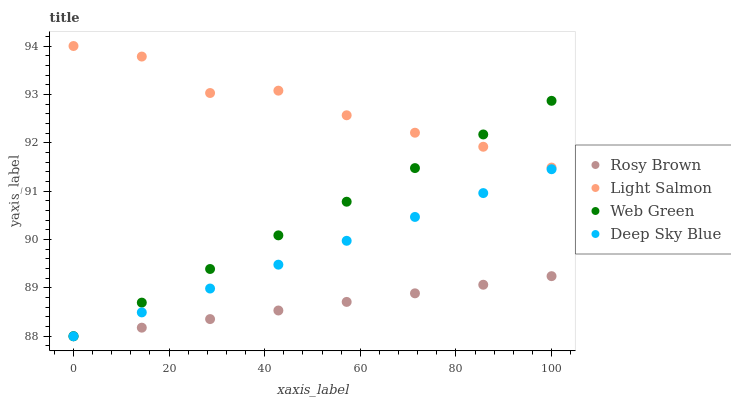Does Rosy Brown have the minimum area under the curve?
Answer yes or no. Yes. Does Light Salmon have the maximum area under the curve?
Answer yes or no. Yes. Does Deep Sky Blue have the minimum area under the curve?
Answer yes or no. No. Does Deep Sky Blue have the maximum area under the curve?
Answer yes or no. No. Is Rosy Brown the smoothest?
Answer yes or no. Yes. Is Light Salmon the roughest?
Answer yes or no. Yes. Is Deep Sky Blue the smoothest?
Answer yes or no. No. Is Deep Sky Blue the roughest?
Answer yes or no. No. Does Rosy Brown have the lowest value?
Answer yes or no. Yes. Does Light Salmon have the highest value?
Answer yes or no. Yes. Does Deep Sky Blue have the highest value?
Answer yes or no. No. Is Rosy Brown less than Light Salmon?
Answer yes or no. Yes. Is Light Salmon greater than Deep Sky Blue?
Answer yes or no. Yes. Does Light Salmon intersect Web Green?
Answer yes or no. Yes. Is Light Salmon less than Web Green?
Answer yes or no. No. Is Light Salmon greater than Web Green?
Answer yes or no. No. Does Rosy Brown intersect Light Salmon?
Answer yes or no. No. 